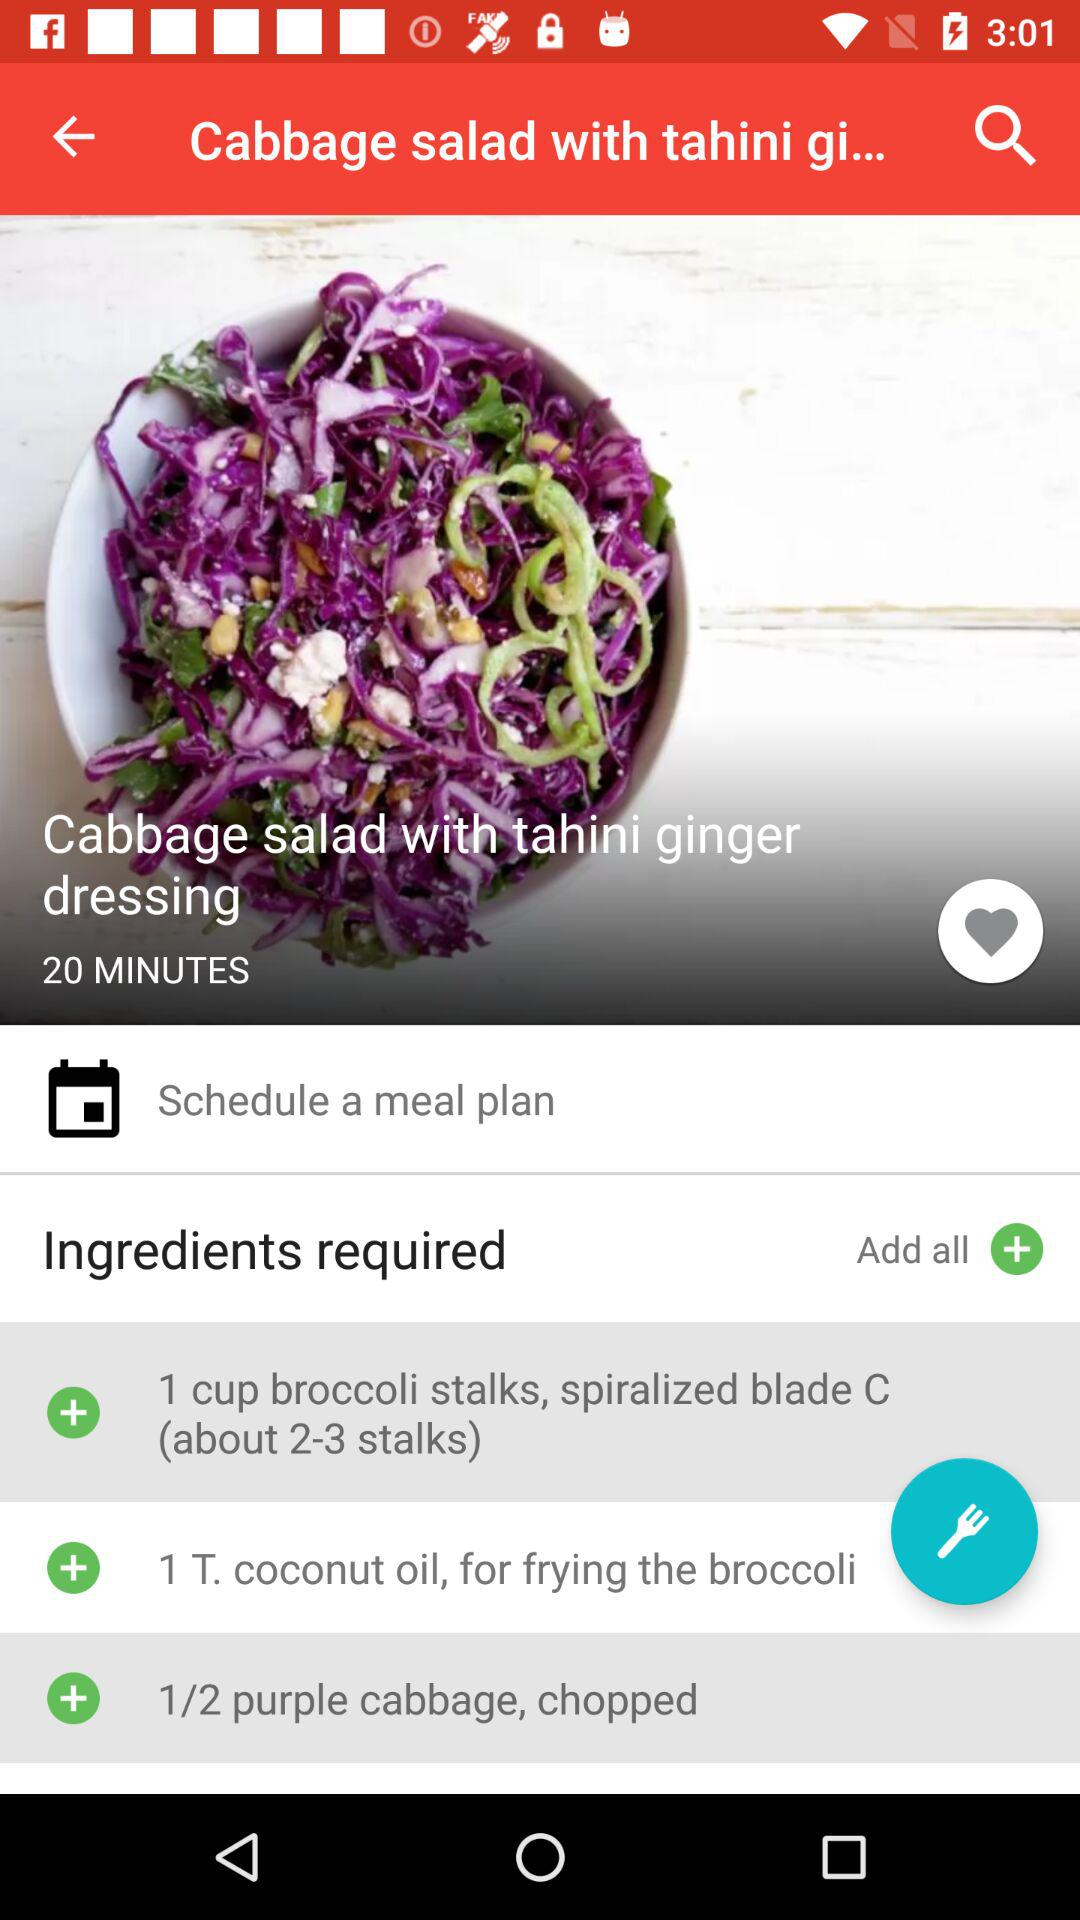How many minutes does it take to make this dish?
Answer the question using a single word or phrase. 20 minutes 